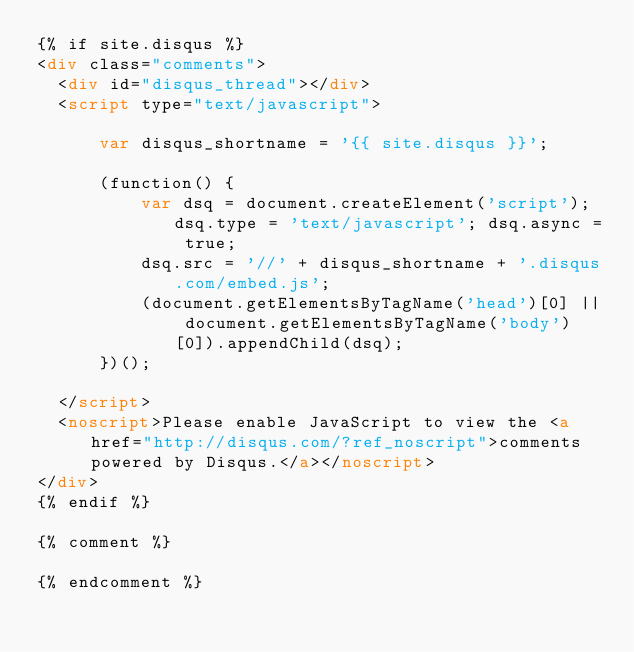Convert code to text. <code><loc_0><loc_0><loc_500><loc_500><_HTML_>{% if site.disqus %}
<div class="comments">
	<div id="disqus_thread"></div>
	<script type="text/javascript">

	    var disqus_shortname = '{{ site.disqus }}';

	    (function() {
	        var dsq = document.createElement('script'); dsq.type = 'text/javascript'; dsq.async = true;
	        dsq.src = '//' + disqus_shortname + '.disqus.com/embed.js';
	        (document.getElementsByTagName('head')[0] || document.getElementsByTagName('body')[0]).appendChild(dsq);
	    })();

	</script>
	<noscript>Please enable JavaScript to view the <a href="http://disqus.com/?ref_noscript">comments powered by Disqus.</a></noscript>
</div>
{% endif %}

{% comment %}

{% endcomment %}</code> 